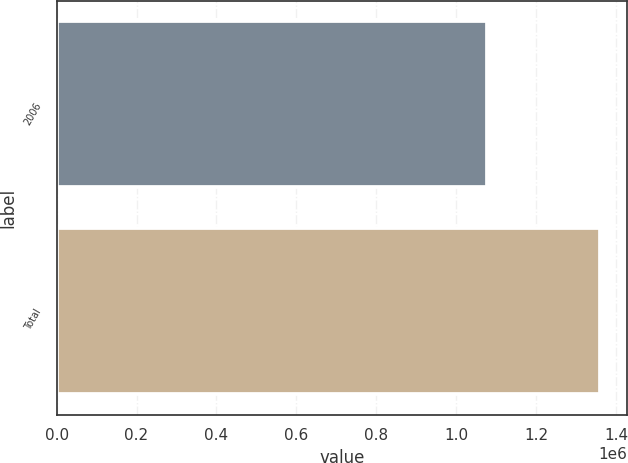<chart> <loc_0><loc_0><loc_500><loc_500><bar_chart><fcel>2006<fcel>Total<nl><fcel>1.07658e+06<fcel>1.36008e+06<nl></chart> 